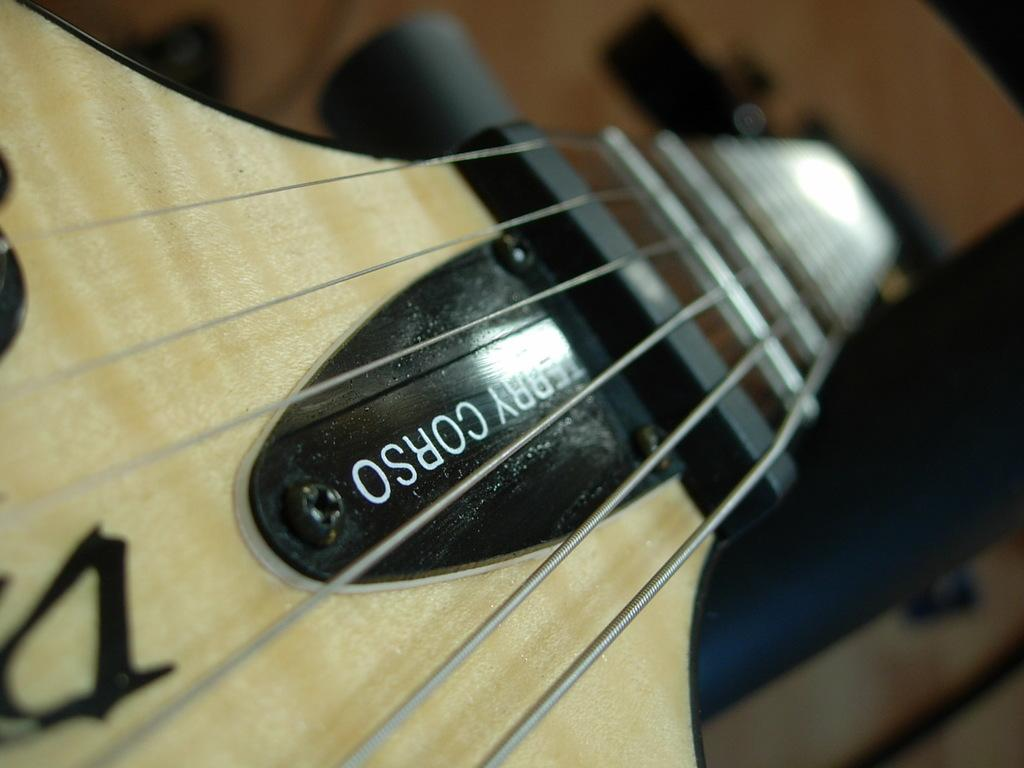What is the main focus of the image? The image provides a closer view of guitar strings. What part of a musical instrument can be seen in the image? The guitar strings are the part of a musical instrument that can be seen in the image. What might be the purpose of this close-up view? The close-up view might be to show the details of the guitar strings or to highlight their importance in playing the instrument. How many layers of wax can be seen on the wall in the image? There is no wall or wax present in the image; it focuses solely on guitar strings. 